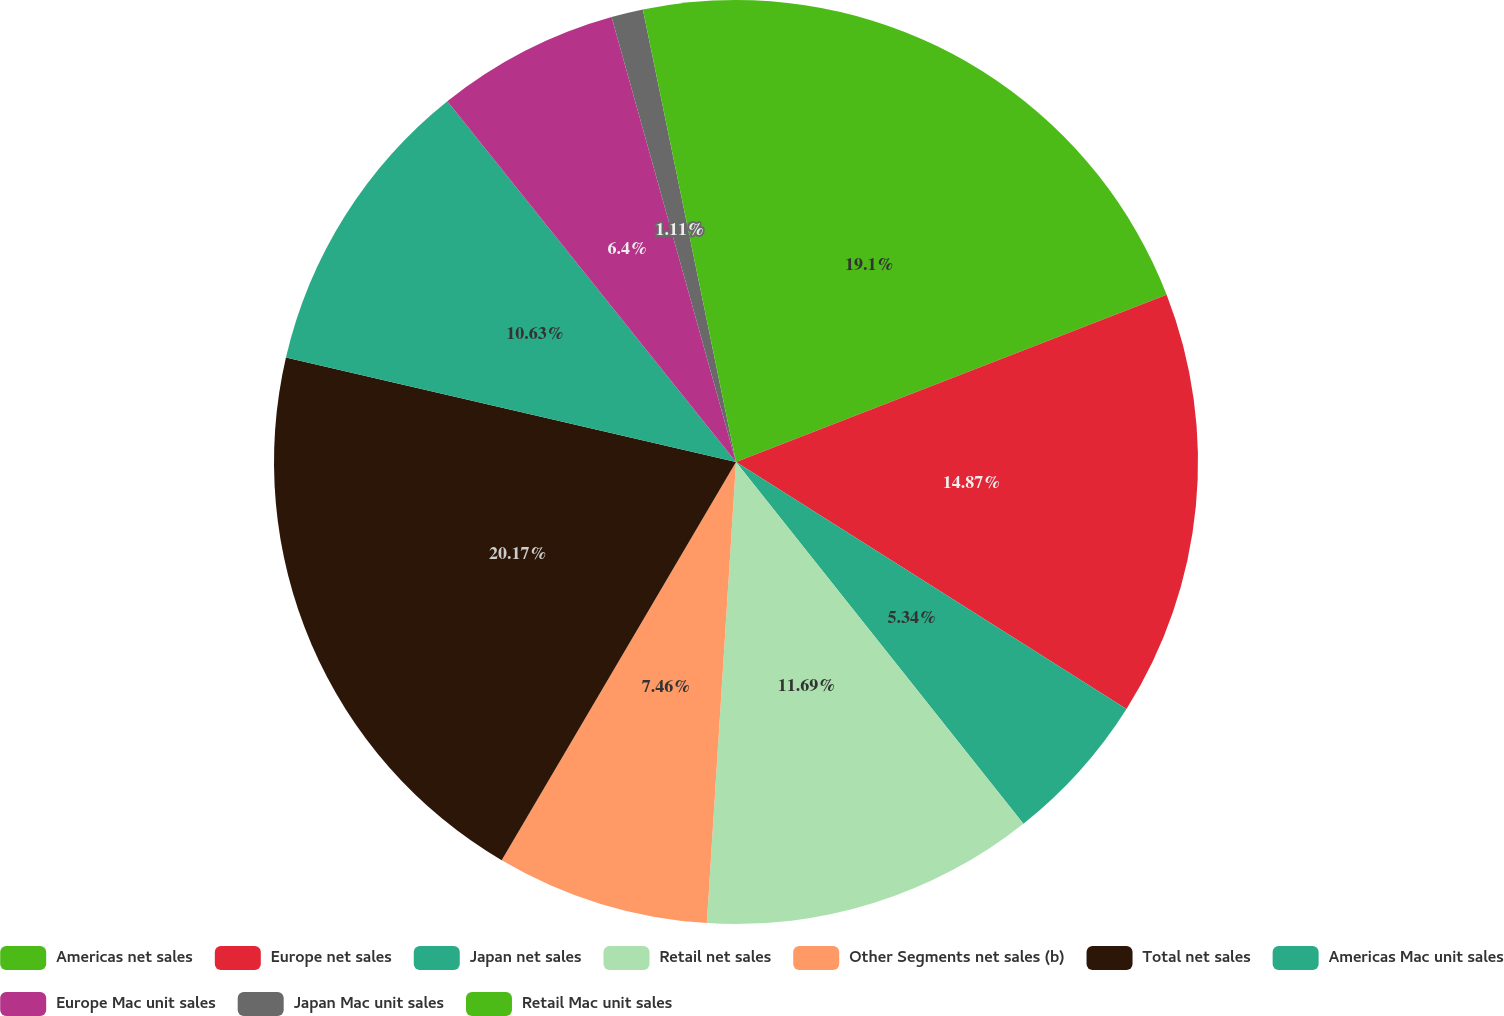<chart> <loc_0><loc_0><loc_500><loc_500><pie_chart><fcel>Americas net sales<fcel>Europe net sales<fcel>Japan net sales<fcel>Retail net sales<fcel>Other Segments net sales (b)<fcel>Total net sales<fcel>Americas Mac unit sales<fcel>Europe Mac unit sales<fcel>Japan Mac unit sales<fcel>Retail Mac unit sales<nl><fcel>19.1%<fcel>14.87%<fcel>5.34%<fcel>11.69%<fcel>7.46%<fcel>20.16%<fcel>10.63%<fcel>6.4%<fcel>1.11%<fcel>3.23%<nl></chart> 